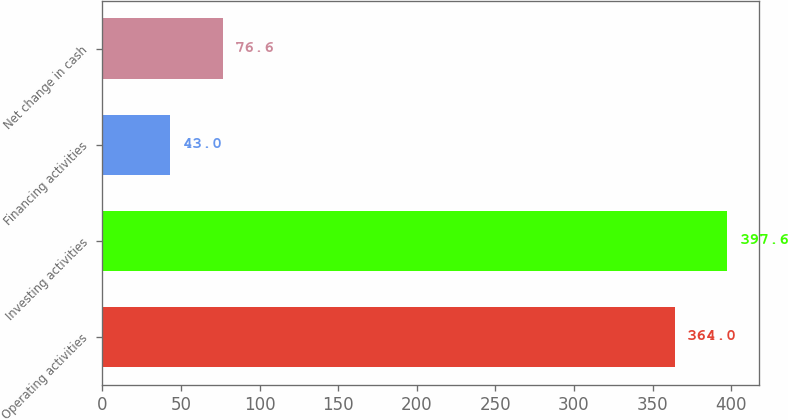Convert chart. <chart><loc_0><loc_0><loc_500><loc_500><bar_chart><fcel>Operating activities<fcel>Investing activities<fcel>Financing activities<fcel>Net change in cash<nl><fcel>364<fcel>397.6<fcel>43<fcel>76.6<nl></chart> 